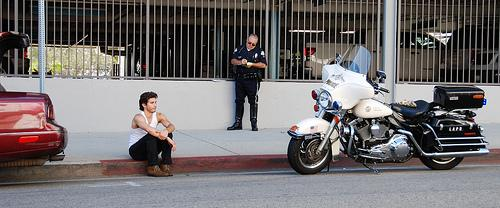Mention the two main vehicles in the image and their colors. A maroon-red car is parked at the curb, and a black and white motorcycle is parked on the sidewalk. Describe the actions of the policeman in the image. The policeman, wearing sunglasses, is standing on the sidewalk and writing a ticket. Provide a brief overview of the scene in the image. A man sits on a red curb by a parked red car with an open trunk, while a policeman writes a ticket nearby and a police motorcycle is parked on the sidewalk. Briefly describe the environment and setting of the image. The scene takes place on a paved city street with a red curb, gray wall and sidewalk, and parked vehicles. Mention the location where the image is taking place and the people present in the scene. On a paved city street with a red curb, a man is sitting on the sidewalk, and a policeman is writing a ticket. Describe the motor vehicle present in the image. A maroon car with an open trunk is parked at the red curb, and a black and white police motorcycle is stationed on the sidewalk. Explain what the man and the officer are doing in the scene. The man is sitting on a red curb near a parked car, while the officer is standing on the sidewalk writing a ticket. List the two main actions happening in the image. A police officer is writing a ticket, and a man is sitting on the curb next to a parked car with an open trunk. What is the focus of the image, and what are some of the most prominent objects present? The focus is on a man sitting on the curb and a policeman writing a ticket, with prominent objects being the red car and police motorcycle. Describe the appearance and attire of the man sitting on the curb. The man sitting on the curb has black hair, wears a white tank top, black jeans, and brown shoes. 